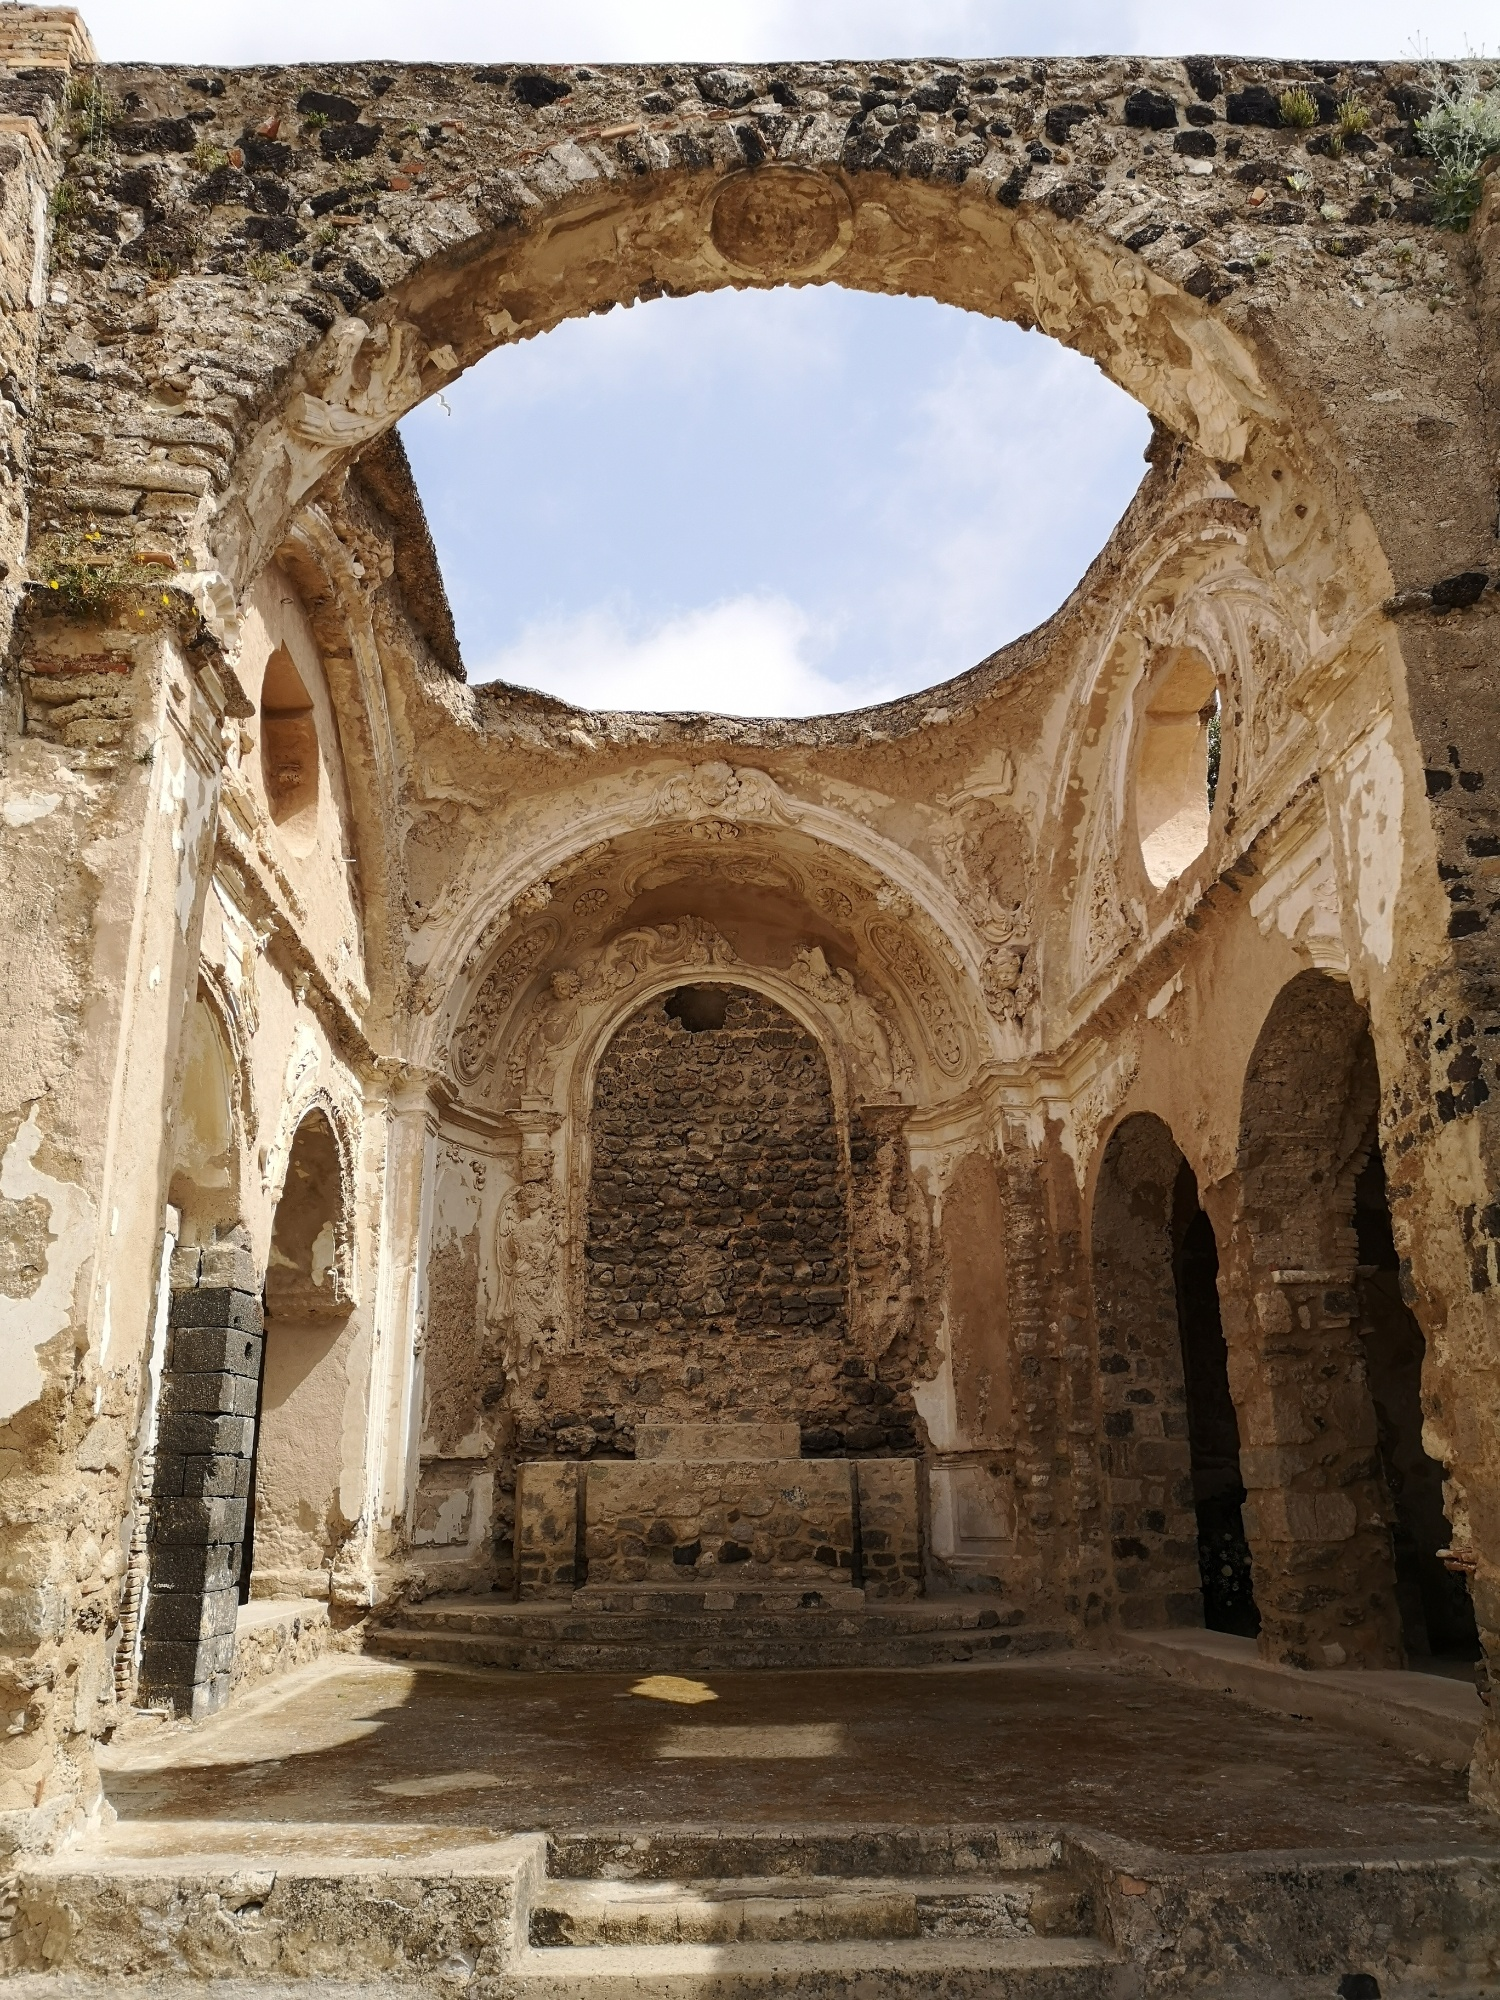Can you tell me more about the architectural style of this structure? The architectural style visible in the image suggests influences from Romanesque and early Gothic design, characterized by robust stone walls, large arches, and detailed carvings. The arches, possibly ribbed vaults, are indicative of Romanesque architecture, which often features semi-circular arches and thick walls. The intricacy of the carvings, especially around the arches and on the walls, shows elements typical of Gothic architecture, particularly in its transitional phase. The absence of pointed arches, which are a hallmark of later Gothic styles, suggests that this structure might be from an earlier period within those movements. Overall, it reflects a blend of strength and detailed artistry, hallmarks of medieval European ecclesiastical architecture. Do you think this place has any historical significance? Given the grandeur and detailed craftsmanship of the structure, it is highly likely that this place holds significant historical importance. Such buildings were often central to community life and religious practices during their time. They might have served as a place of worship, a pilgrimage site, or even a ceremonial center. The detailed carvings could tell stories or depict important religious or historical events, which were common practices to educate and inspire people. Therefore, this ruin probably has a rich history intertwined with the cultural and religious development of its region. 